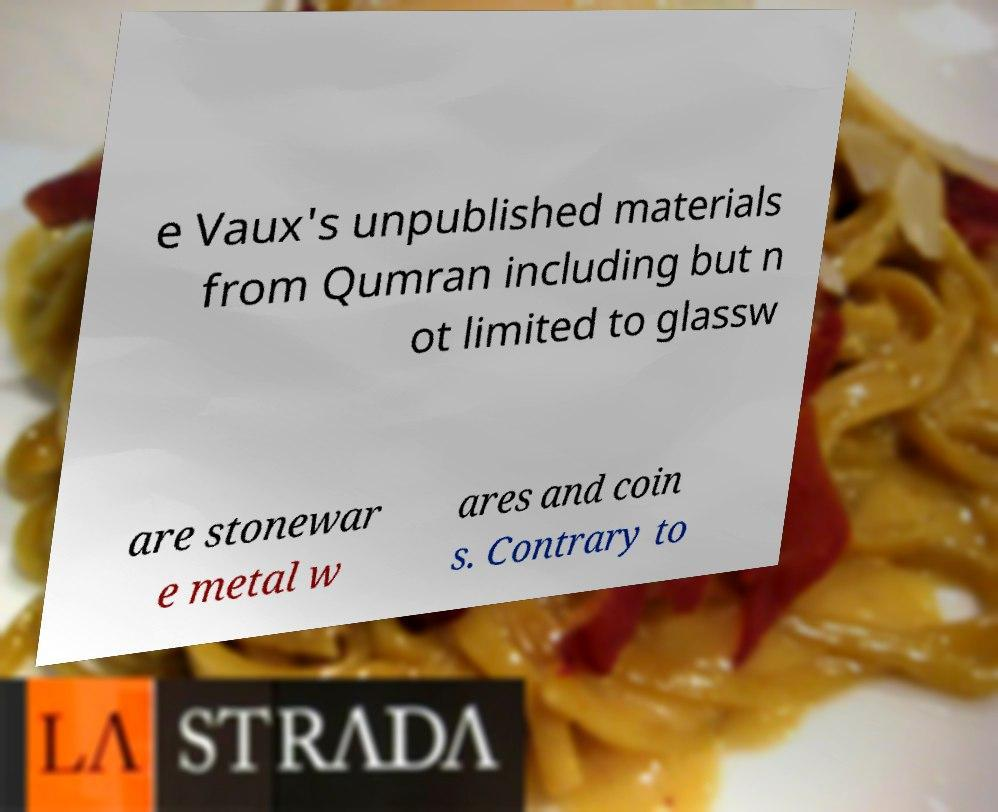I need the written content from this picture converted into text. Can you do that? e Vaux's unpublished materials from Qumran including but n ot limited to glassw are stonewar e metal w ares and coin s. Contrary to 